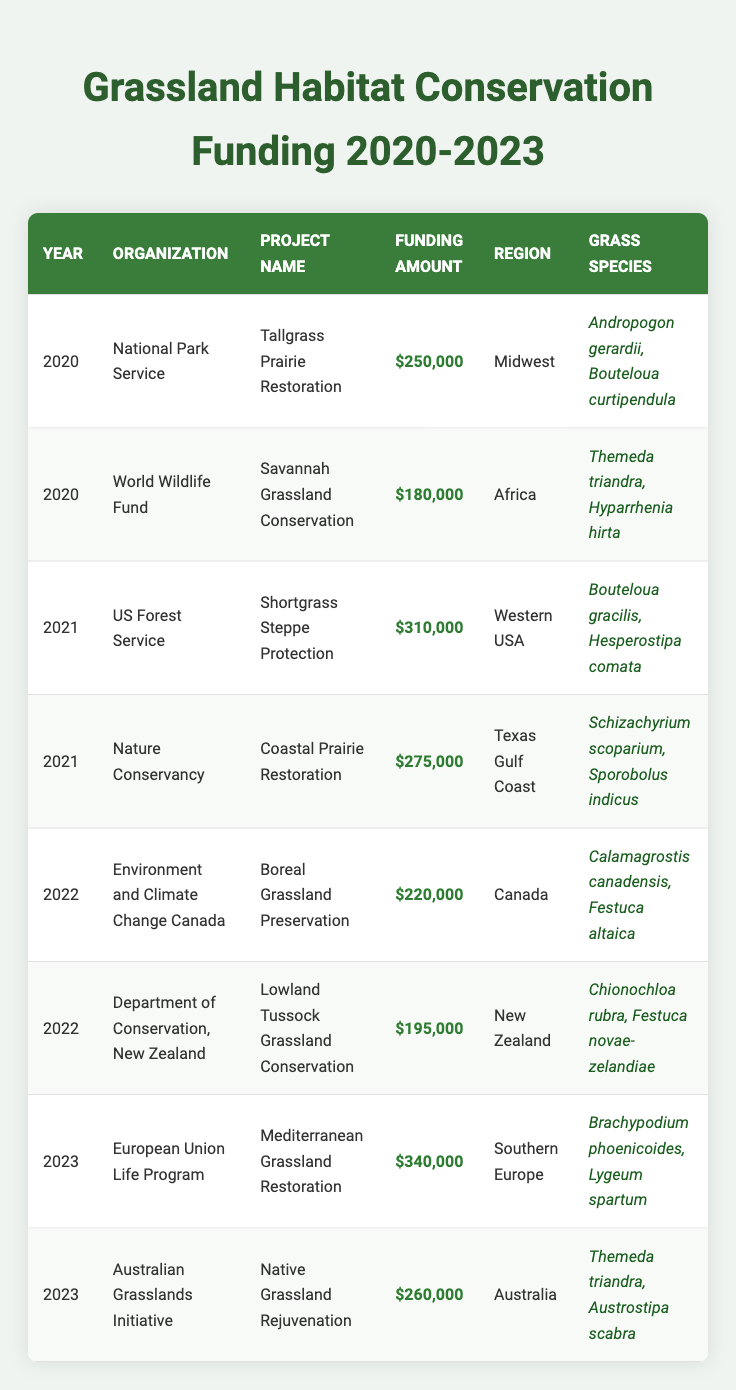What organization funded the highest amount for a grassland conservation project in 2023? The table shows that the European Union Life Program funded the Mediterranean Grassland Restoration project with a funding amount of 340,000 in 2023.
Answer: European Union Life Program How much funding was allocated to the project "Savannah Grassland Conservation"? According to the table, the World Wildlife Fund allocated 180,000 to the Savannah Grassland Conservation project in 2020.
Answer: 180,000 What is the total funding amount allocated for grassland projects in 2022? The table shows the funding amounts for two projects in 2022: 220,000 for the Boreal Grassland Preservation and 195,000 for the Lowland Tussock Grassland Conservation. Adding these amounts together, we get 220,000 + 195,000 = 415,000.
Answer: 415,000 Did the Nature Conservancy fund more in 2021 than the US Forest Service? The funding amount for the Nature Conservancy's Coastal Prairie Restoration project in 2021 was 275,000, while the US Forest Service's Shortgrass Steppe Protection project received 310,000. Since 275,000 is less than 310,000, the answer is no.
Answer: No What is the average funding amount for all projects listed in 2020? In 2020, there are two funding amounts: 250,000 for the Tallgrass Prairie Restoration and 180,000 for the Savannah Grassland Conservation. To find the average, we sum these amounts (250,000 + 180,000 = 430,000) and divide by 2. Therefore, the average is 430,000 / 2 = 215,000.
Answer: 215,000 